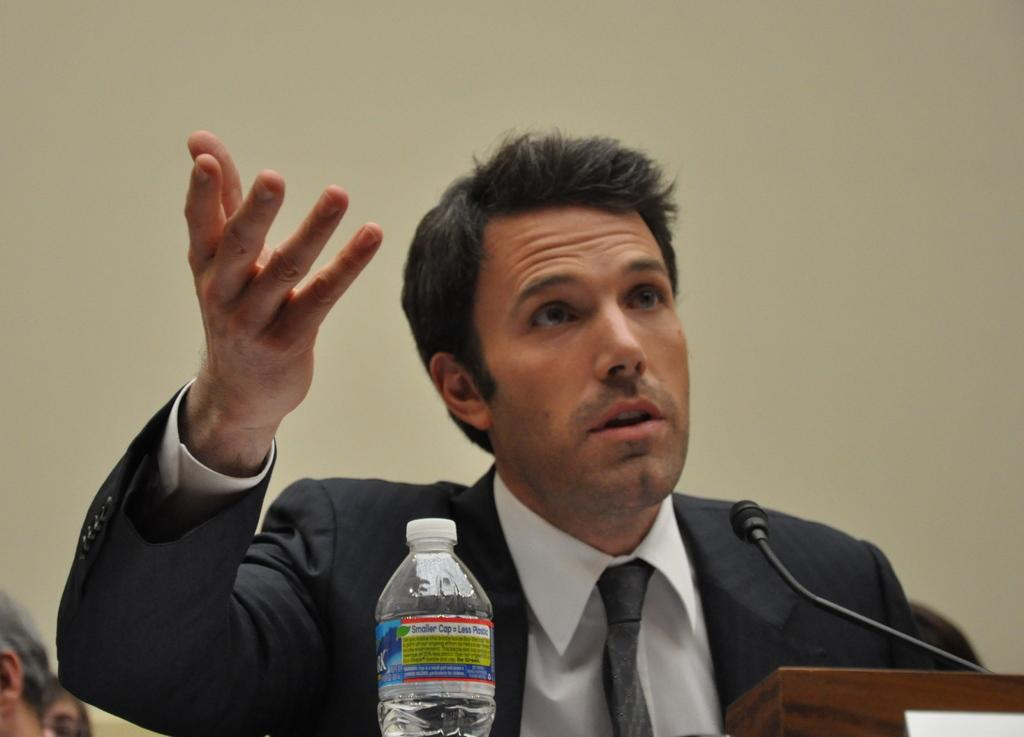Who is the main subject in the image? There is a man in the image. What is the man doing in the image? The man is standing near a podium. What object is on the podium? There is a mic on the podium. What item is near the man? There is a water bottle near the man. What type of clothing is the man wearing? The man is wearing a blazer. What type of lettuce is the man holding in the image? There is no lettuce present in the image; the man is not holding any lettuce. How many teeth can be seen in the image? There are no teeth visible in the image, as it features a man standing near a podium with a mic and a water bottle. 